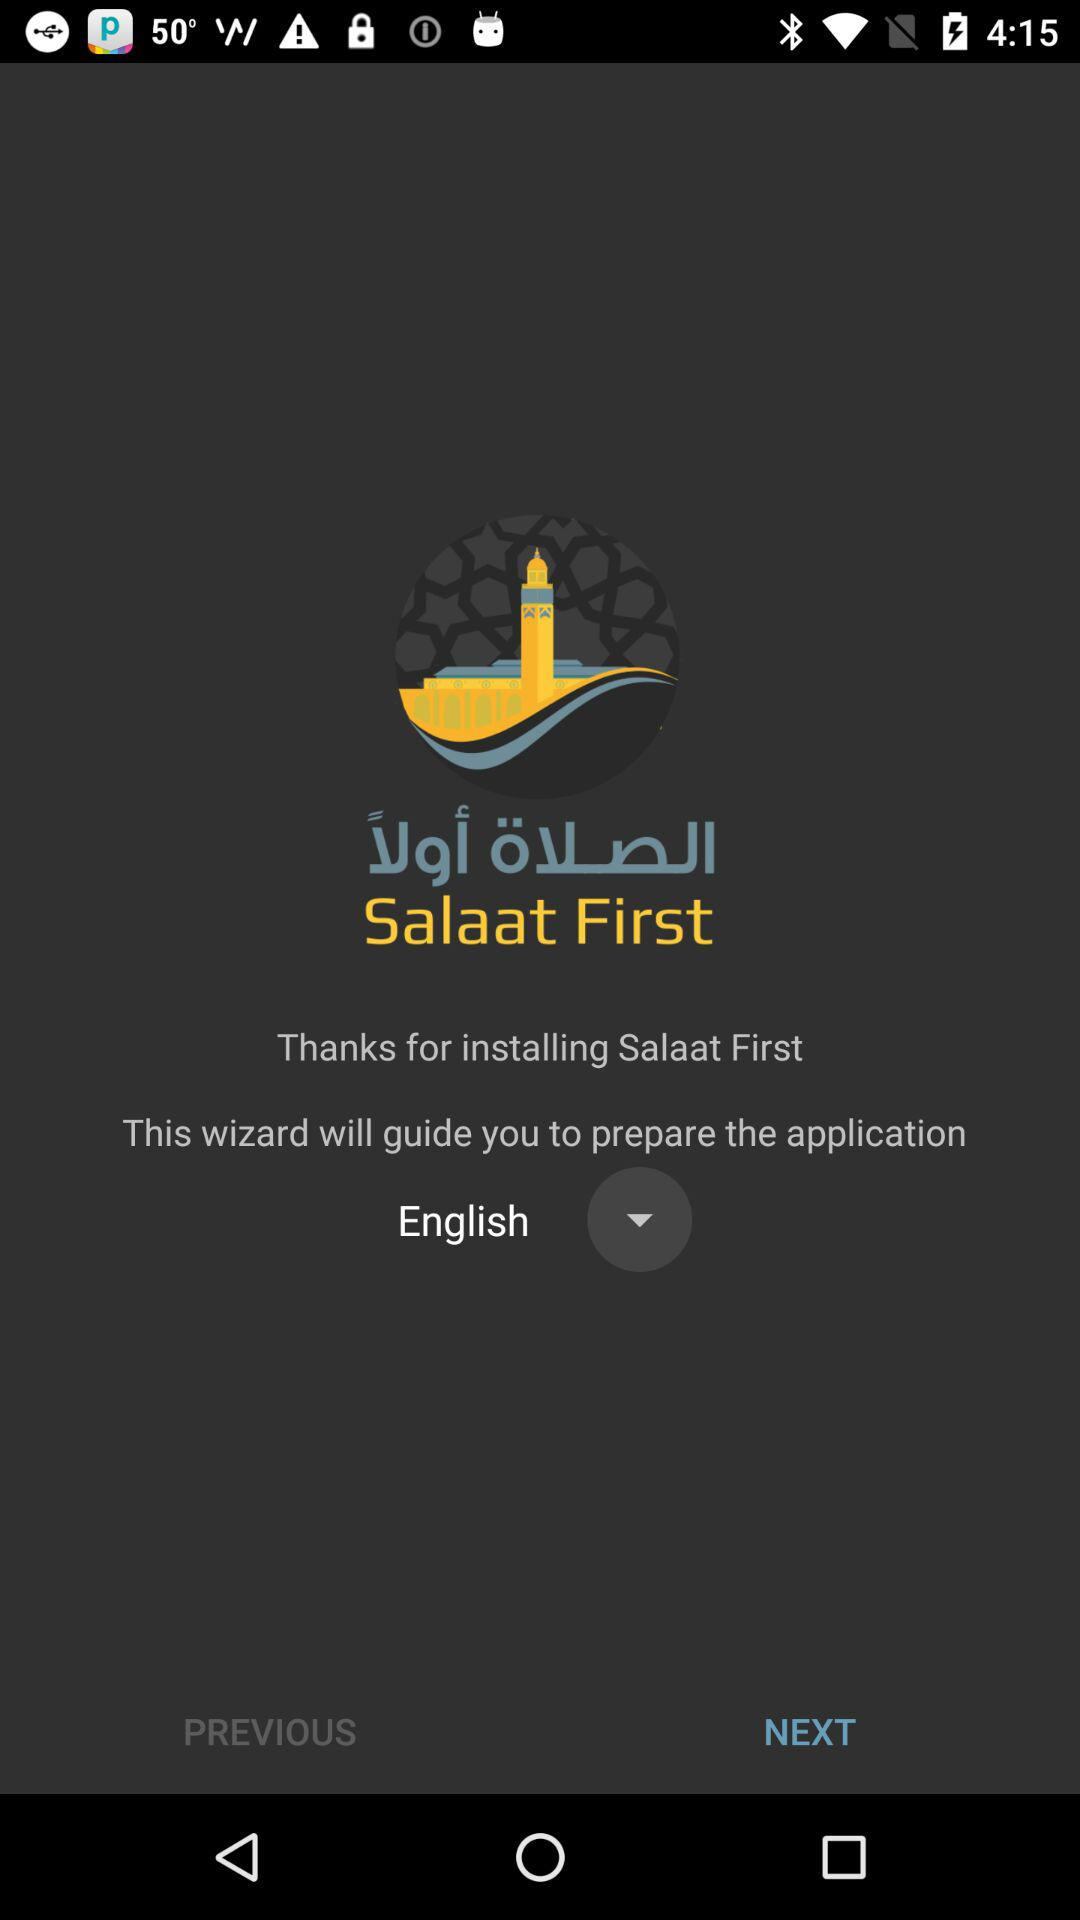What is the language? The language is English. 